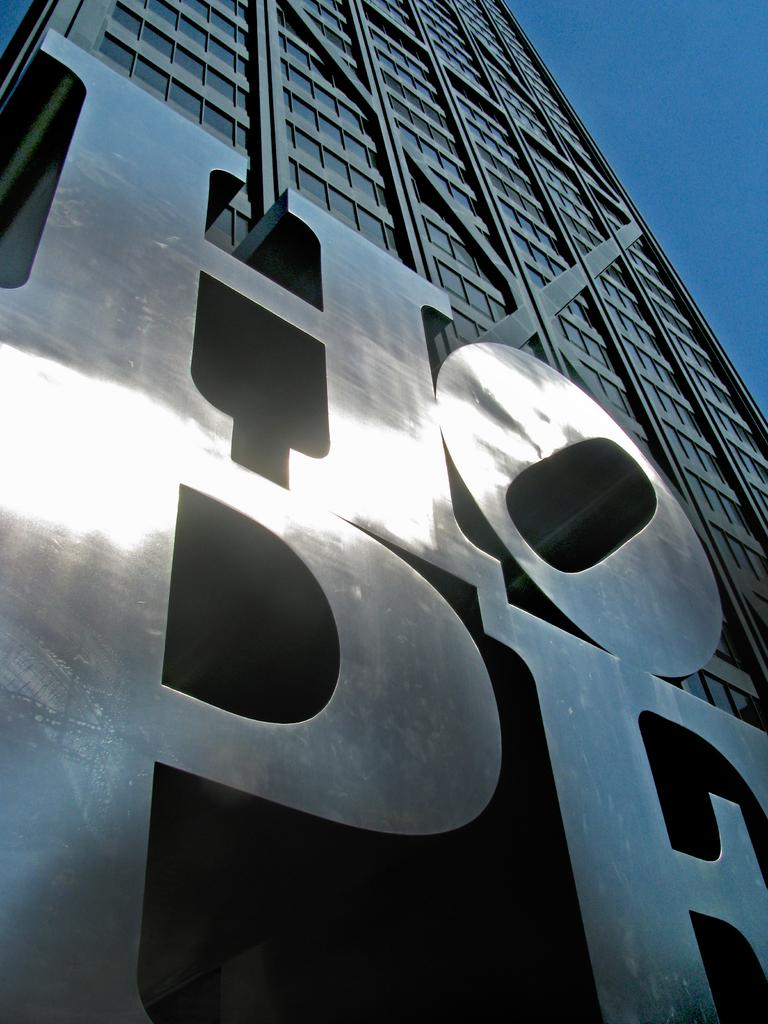What is written on the building in the image? There is text on a building in the image, but the specific words cannot be determined from the provided facts. What can be seen in the background of the image? The sky is visible in the image. How many plants are on the shelf in the image? There is no shelf or plant present in the image. What type of crow is depicted in the image? There is no crow present in the image. 